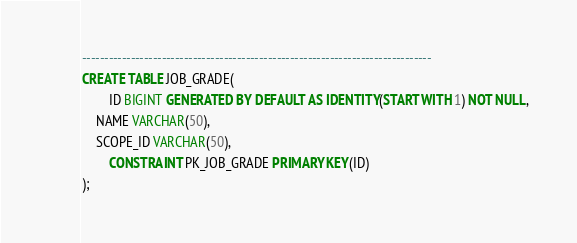Convert code to text. <code><loc_0><loc_0><loc_500><loc_500><_SQL_>-------------------------------------------------------------------------------
CREATE TABLE JOB_GRADE(
        ID BIGINT GENERATED BY DEFAULT AS IDENTITY(START WITH 1) NOT NULL,
	NAME VARCHAR(50),
	SCOPE_ID VARCHAR(50),
        CONSTRAINT PK_JOB_GRADE PRIMARY KEY(ID)
);

</code> 